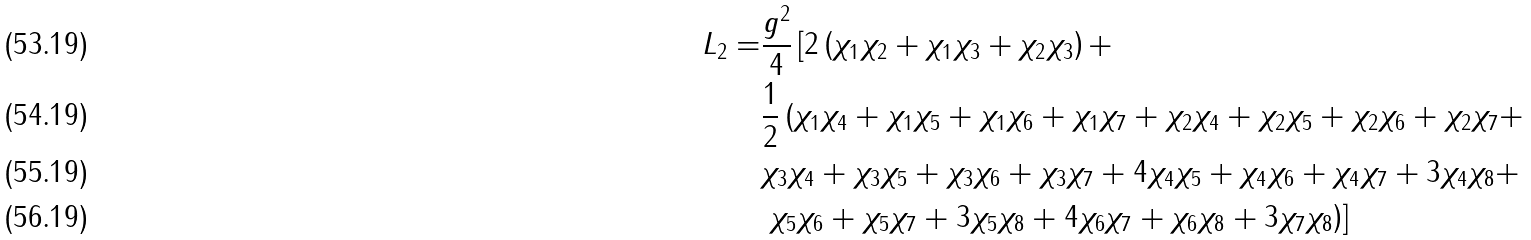<formula> <loc_0><loc_0><loc_500><loc_500>L _ { 2 } = & \frac { g ^ { 2 } } { 4 } \left [ 2 \left ( \chi _ { 1 } \chi _ { 2 } + \chi _ { 1 } \chi _ { 3 } + \chi _ { 2 } \chi _ { 3 } \right ) + \right . \\ & \frac { 1 } { 2 } \left ( \chi _ { 1 } \chi _ { 4 } + \chi _ { 1 } \chi _ { 5 } + \chi _ { 1 } \chi _ { 6 } + \chi _ { 1 } \chi _ { 7 } + \chi _ { 2 } \chi _ { 4 } + \chi _ { 2 } \chi _ { 5 } + \chi _ { 2 } \chi _ { 6 } + \chi _ { 2 } \chi _ { 7 } + \right . \\ & \chi _ { 3 } \chi _ { 4 } + \chi _ { 3 } \chi _ { 5 } + \chi _ { 3 } \chi _ { 6 } + \chi _ { 3 } \chi _ { 7 } + 4 \chi _ { 4 } \chi _ { 5 } + \chi _ { 4 } \chi _ { 6 } + \chi _ { 4 } \chi _ { 7 } + 3 \chi _ { 4 } \chi _ { 8 } + \\ & \left . \left . \chi _ { 5 } \chi _ { 6 } + \chi _ { 5 } \chi _ { 7 } + 3 \chi _ { 5 } \chi _ { 8 } + 4 \chi _ { 6 } \chi _ { 7 } + \chi _ { 6 } \chi _ { 8 } + 3 \chi _ { 7 } \chi _ { 8 } \right ) \right ]</formula> 